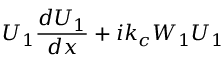<formula> <loc_0><loc_0><loc_500><loc_500>U _ { 1 } \frac { d U _ { 1 } } { d x } + i k _ { c } W _ { 1 } U _ { 1 }</formula> 